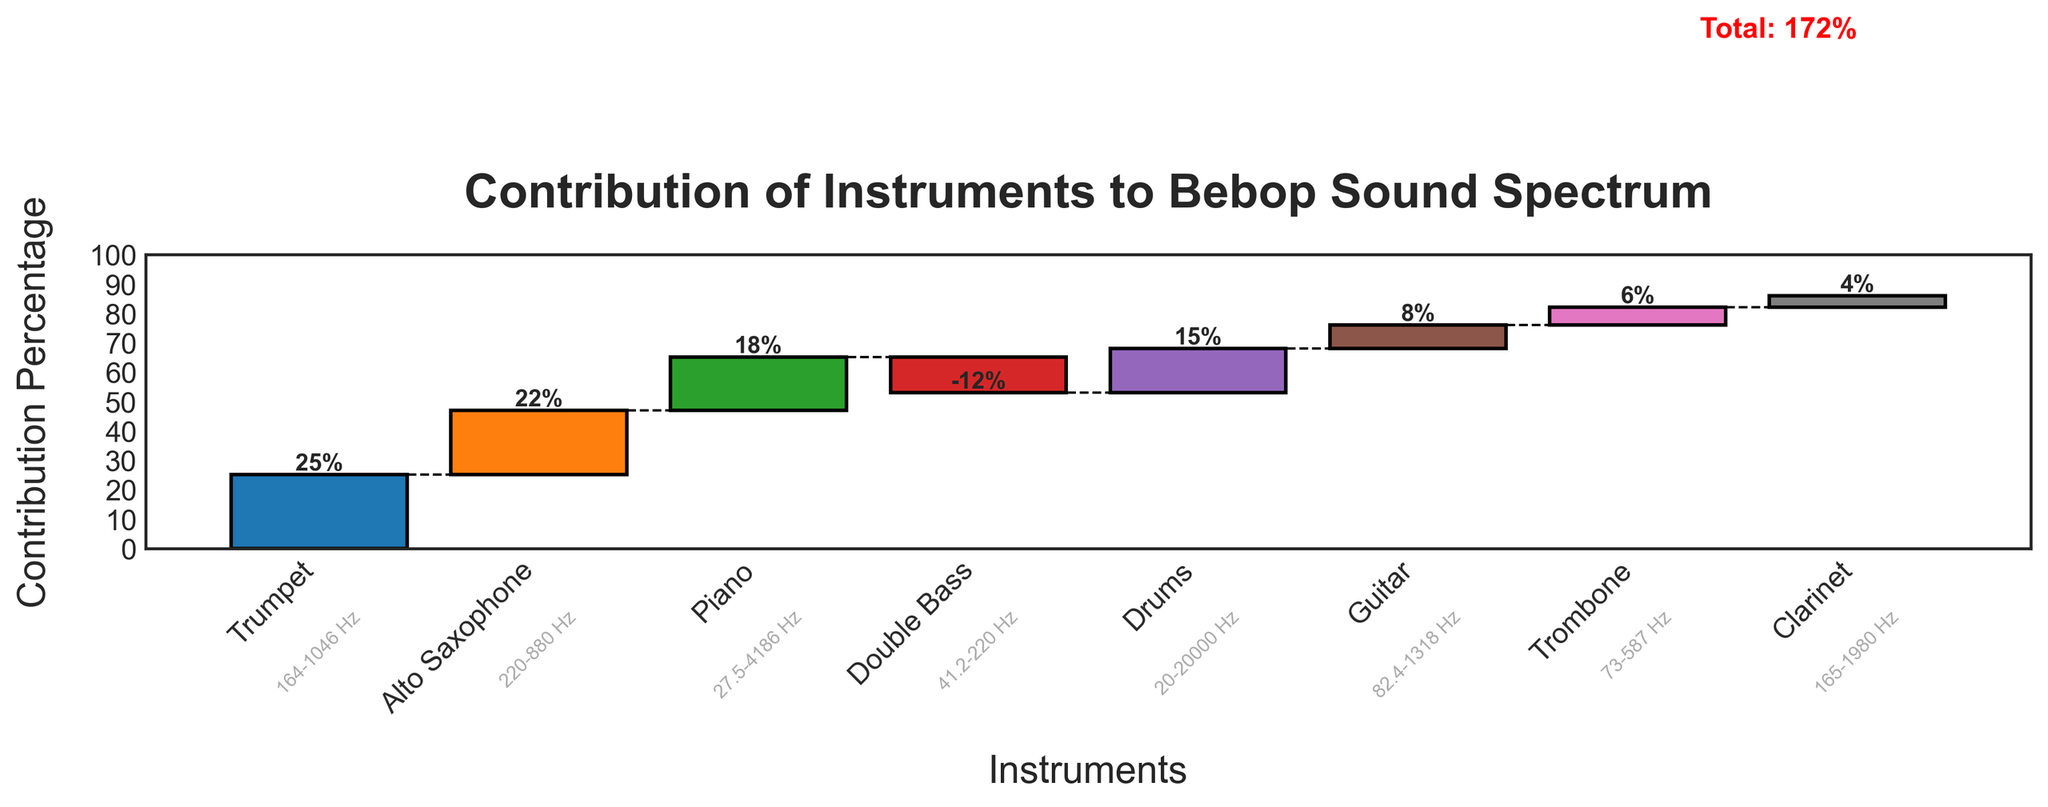How many instruments are contributing to the bebop sound spectrum as shown in the chart? There are 8 instruments listed in the chart, not including the 'Total'. You can see this by counting the bars representing each instrument.
Answer: 8 What is the overall contribution percentage of the trumpet? The figure shows a bar for the trumpet with a label indicating a contribution percentage of 25%.
Answer: 25% By how many percentage points is the contribution of the alto saxophone greater than that of the clarinet? The alto saxophone contributes 22%, and the clarinet contributes 4%. The difference is calculated as 22% - 4%.
Answer: 18 Which instrument has a negative contribution to the overall sound spectrum? The double bass is the only instrument with a negative contribution, indicated by the downward direction of its bar labeled -12%.
Answer: Double Bass What is the contribution percentage of percussion instruments (drums only)? The drum's bar indicates a contribution percentage of 15%.
Answer: 15% Calculate the total contribution percentage shown by summing up the individual contributions. Does it match the total line in red on the chart? Summing the contributions: 25 (Trumpet) + 22 (Alto Saxophone) + 18 (Piano) - 12 (Double Bass) + 15 (Drums) + 8 (Guitar) + 6 (Trombone) + 4 (Clarinet) = 86%. It matches the total line in red, which is marked at 86%.
Answer: 86% Which instrument has the smallest positive contribution to the bebop sound spectrum? The clarinet has the smallest positive contribution to the sound spectrum, shown by the smallest upward bar labeled 4%.
Answer: Clarinet How many instruments have a contribution percentage greater than 10%? The trumpet (25%), alto saxophone (22%), piano (18%), and drums (15%) all have contributions greater than 10%, totaling 4 instruments.
Answer: 4 